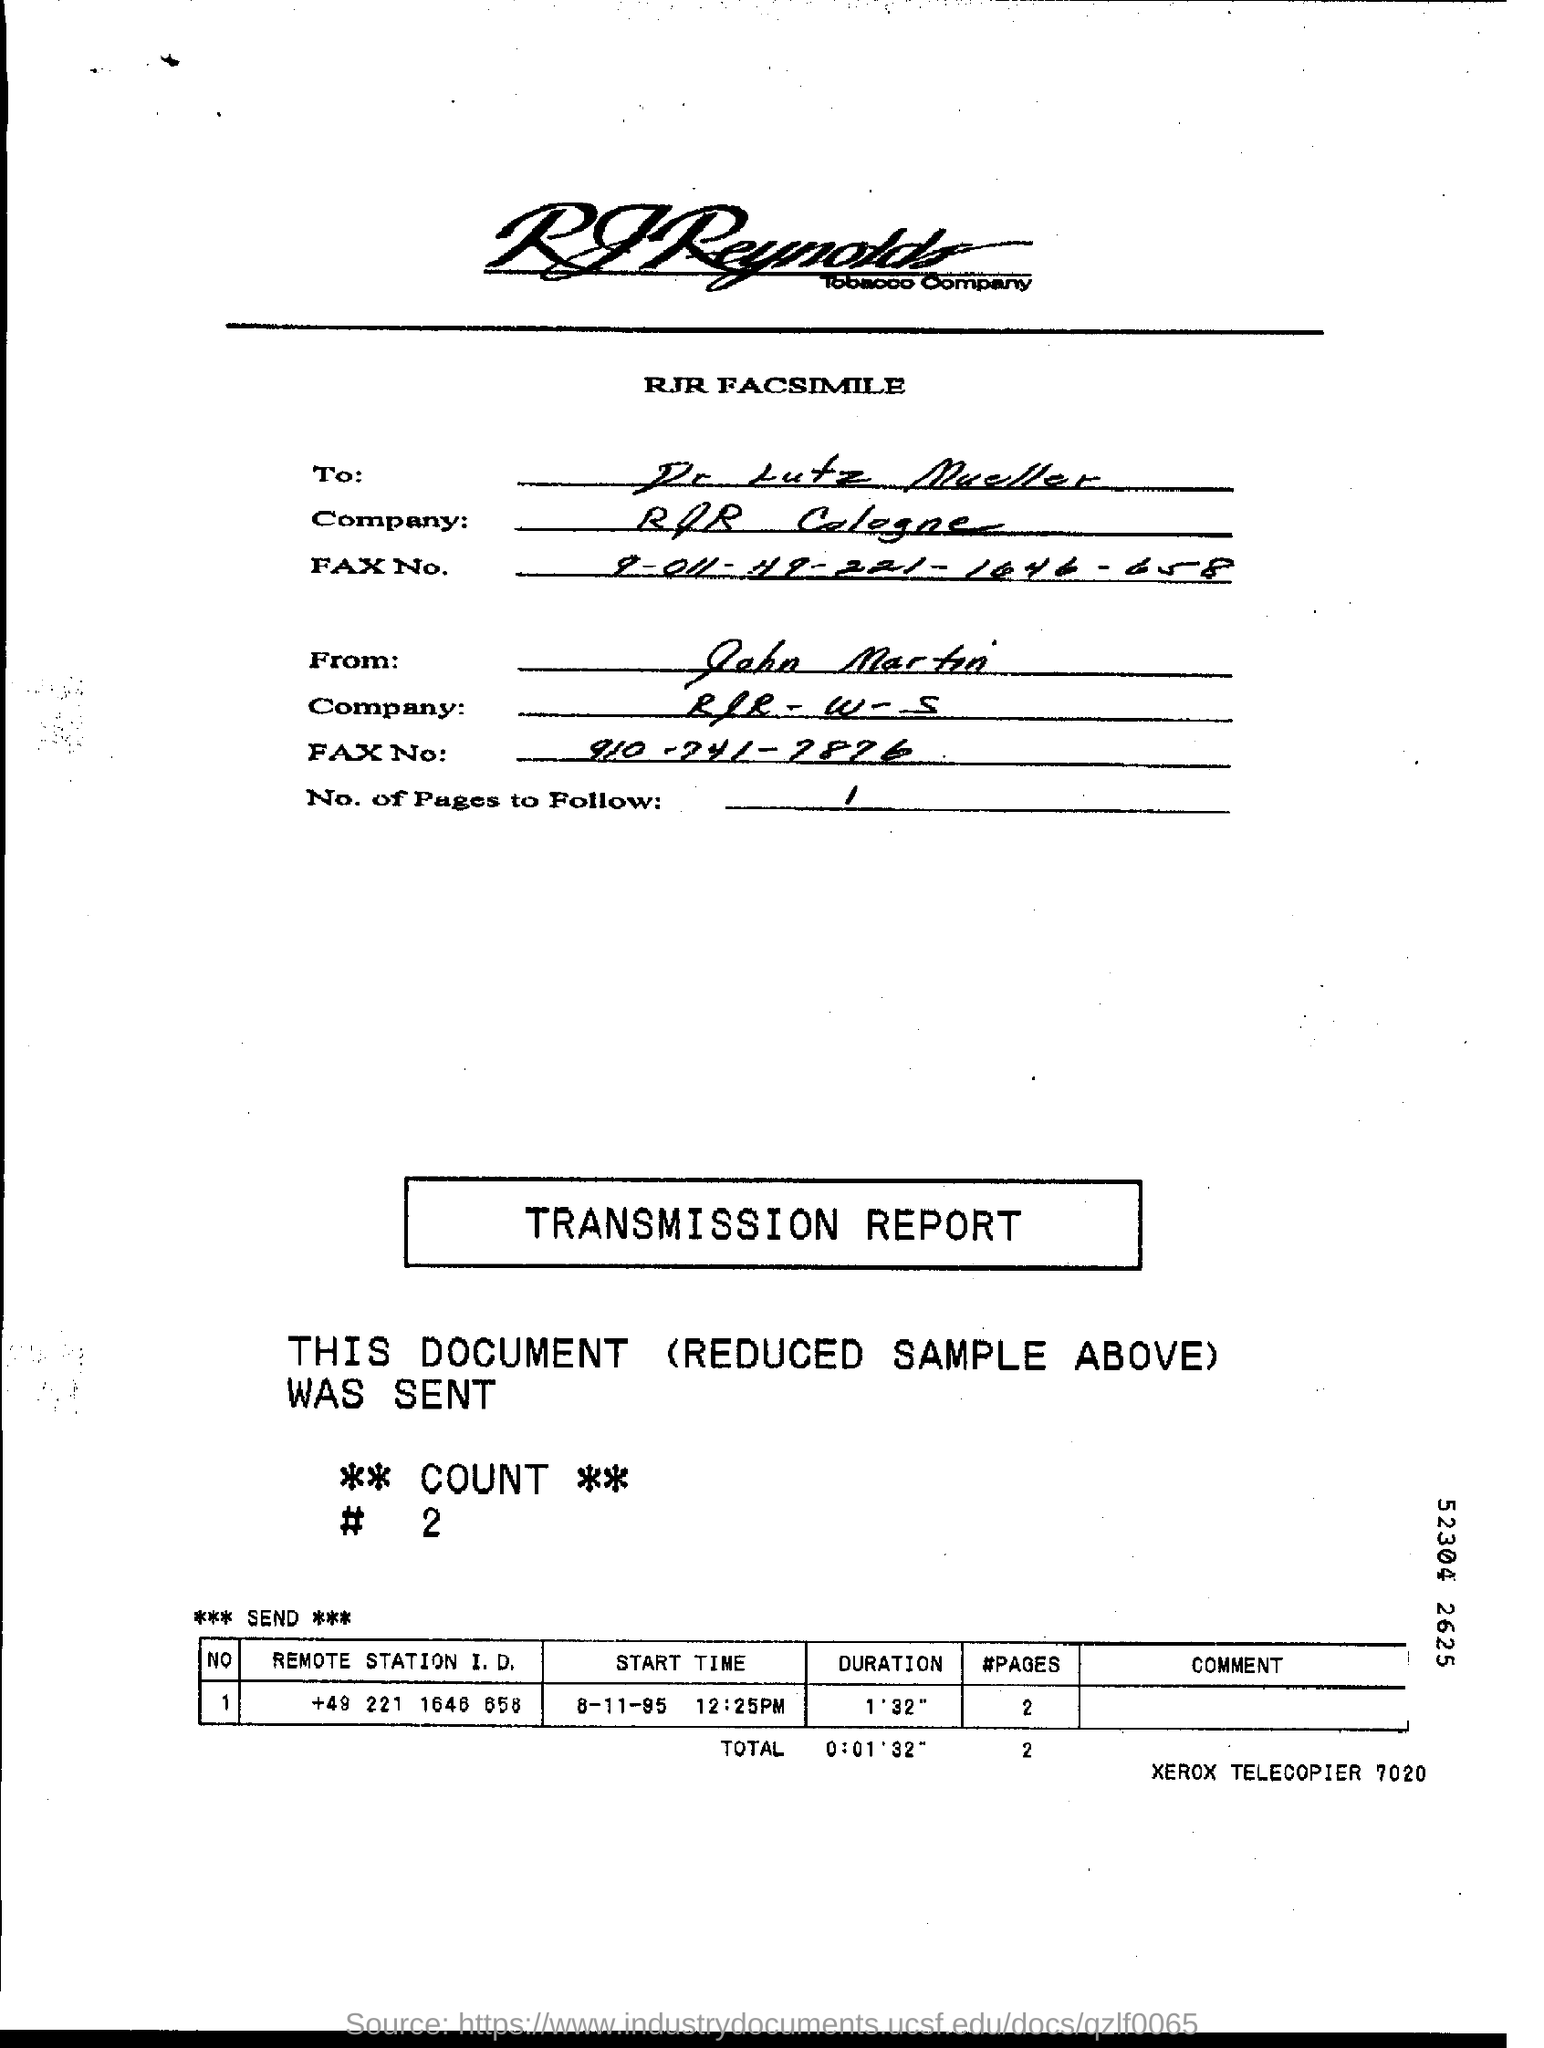Who is this Fax from?
Provide a succinct answer. John Martin. To Whom is this Fax addressed to?
Provide a short and direct response. Dr Lutz Mueller. What is the "Start Time" for "Remote station" "+49 221 1645 658"?
Keep it short and to the point. 8-11-95 12:25PM. 